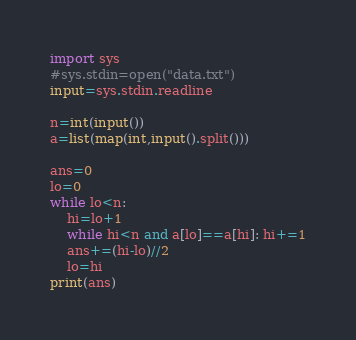<code> <loc_0><loc_0><loc_500><loc_500><_Python_>
import sys
#sys.stdin=open("data.txt")
input=sys.stdin.readline

n=int(input())
a=list(map(int,input().split()))

ans=0
lo=0
while lo<n:
    hi=lo+1
    while hi<n and a[lo]==a[hi]: hi+=1
    ans+=(hi-lo)//2
    lo=hi
print(ans)
</code> 